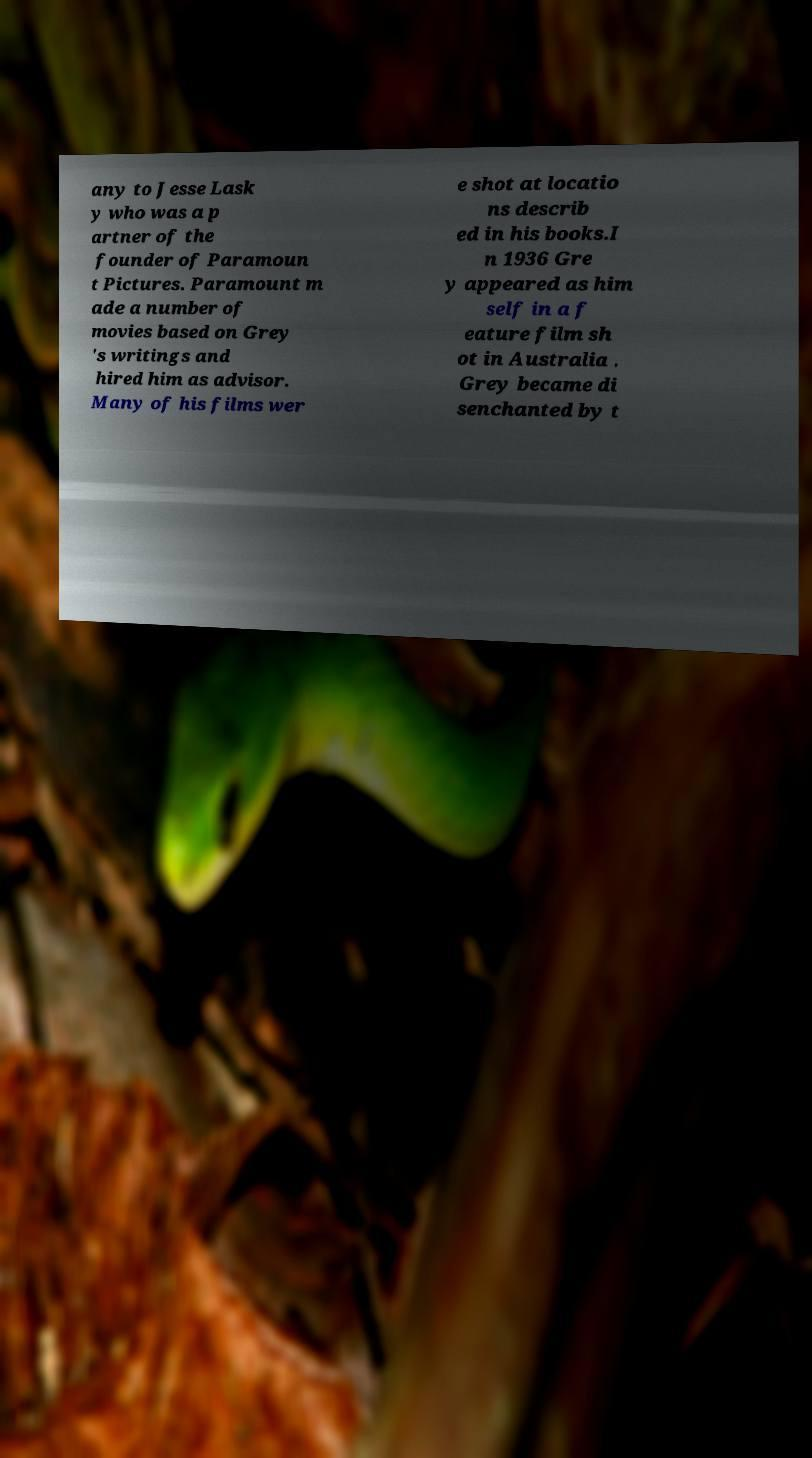Can you read and provide the text displayed in the image?This photo seems to have some interesting text. Can you extract and type it out for me? any to Jesse Lask y who was a p artner of the founder of Paramoun t Pictures. Paramount m ade a number of movies based on Grey 's writings and hired him as advisor. Many of his films wer e shot at locatio ns describ ed in his books.I n 1936 Gre y appeared as him self in a f eature film sh ot in Australia . Grey became di senchanted by t 